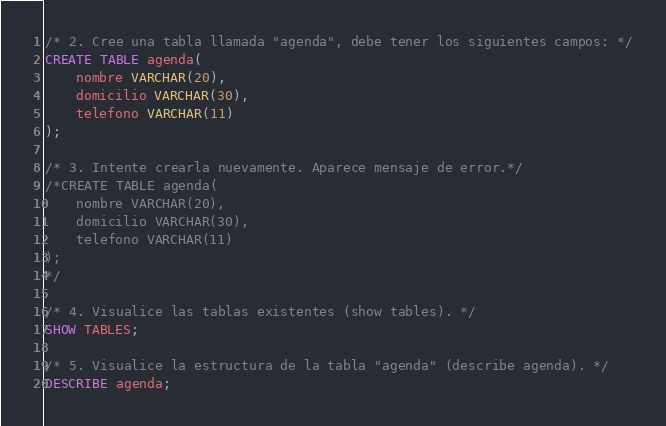<code> <loc_0><loc_0><loc_500><loc_500><_SQL_>/* 2. Cree una tabla llamada "agenda", debe tener los siguientes campos: */
CREATE TABLE agenda(
    nombre VARCHAR(20),
    domicilio VARCHAR(30),
    telefono VARCHAR(11)
);

/* 3. Intente crearla nuevamente. Aparece mensaje de error.*/
/*CREATE TABLE agenda(
    nombre VARCHAR(20),
    domicilio VARCHAR(30),
    telefono VARCHAR(11)
);
*/

/* 4. Visualice las tablas existentes (show tables). */
SHOW TABLES;

/* 5. Visualice la estructura de la tabla "agenda" (describe agenda). */
DESCRIBE agenda;
</code> 